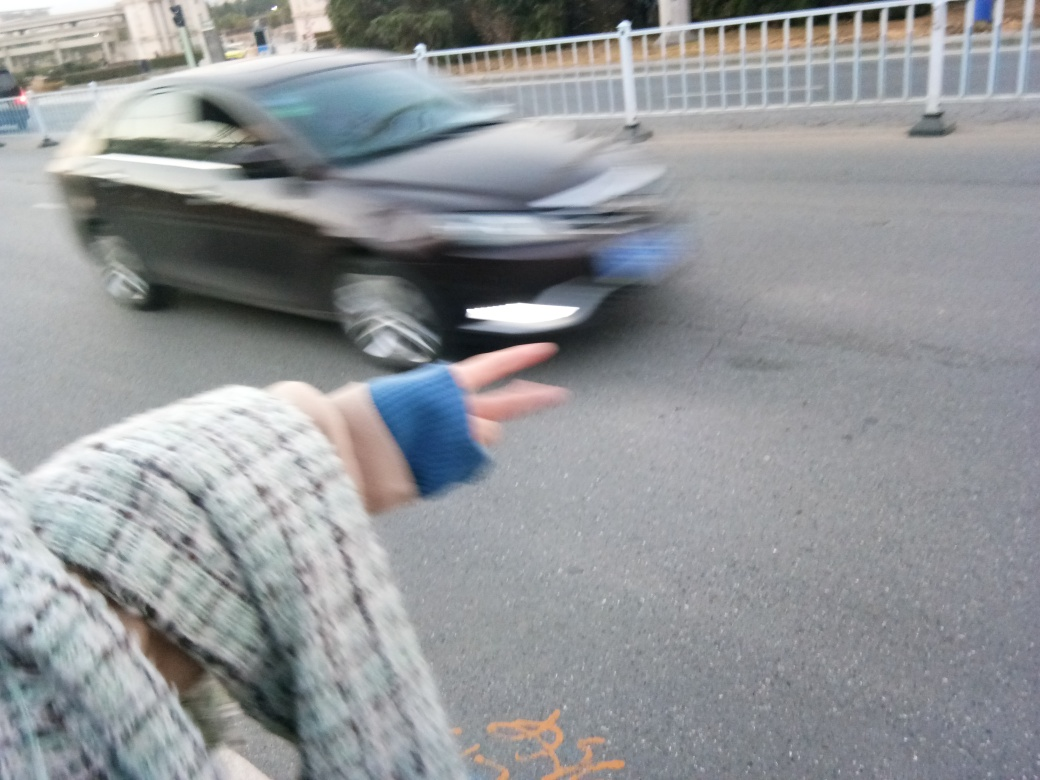Can you describe the environment that is depicted in the photo? The photo appears to capture an everyday street scene during daylight, with a blurred car in motion suggesting busy traffic. The presence of guardrails hints at a structured road setting, possibly near a crossing or an area with pedestrian access. The lighting conditions and peaceful surroundings might indicate late afternoon or an overcast day. 